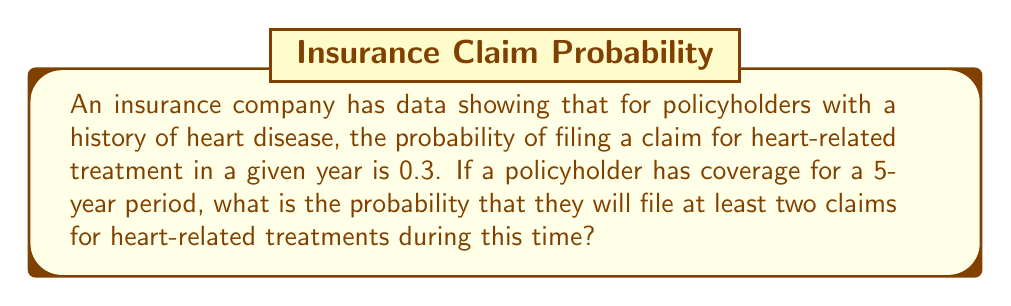Provide a solution to this math problem. To solve this problem, we'll use the binomial probability distribution and the complement rule.

Step 1: Define the parameters
n = 5 (number of years)
p = 0.3 (probability of filing a claim in a given year)
q = 1 - p = 0.7 (probability of not filing a claim in a given year)

Step 2: Calculate the probability of filing exactly 0 or 1 claim in 5 years
P(X = 0) = $${5 \choose 0} (0.3)^0 (0.7)^5 = 0.16807$$
P(X = 1) = $${5 \choose 1} (0.3)^1 (0.7)^4 = 0.36015$$

Step 3: Sum the probabilities of 0 and 1 claims
P(X ≤ 1) = P(X = 0) + P(X = 1) = 0.16807 + 0.36015 = 0.52822

Step 4: Use the complement rule to find the probability of at least 2 claims
P(X ≥ 2) = 1 - P(X ≤ 1) = 1 - 0.52822 = 0.47178

Therefore, the probability of filing at least two claims for heart-related treatments during the 5-year policy period is approximately 0.47178 or 47.178%.
Answer: 0.47178 